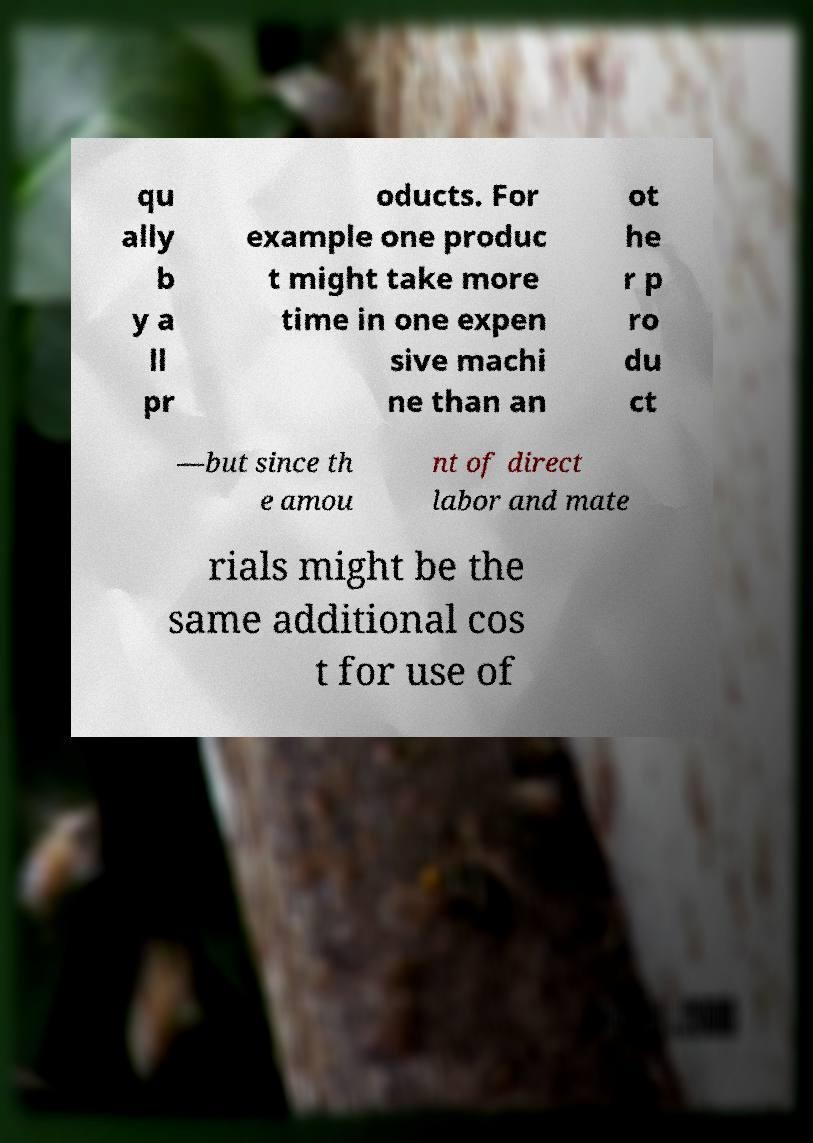What messages or text are displayed in this image? I need them in a readable, typed format. qu ally b y a ll pr oducts. For example one produc t might take more time in one expen sive machi ne than an ot he r p ro du ct —but since th e amou nt of direct labor and mate rials might be the same additional cos t for use of 